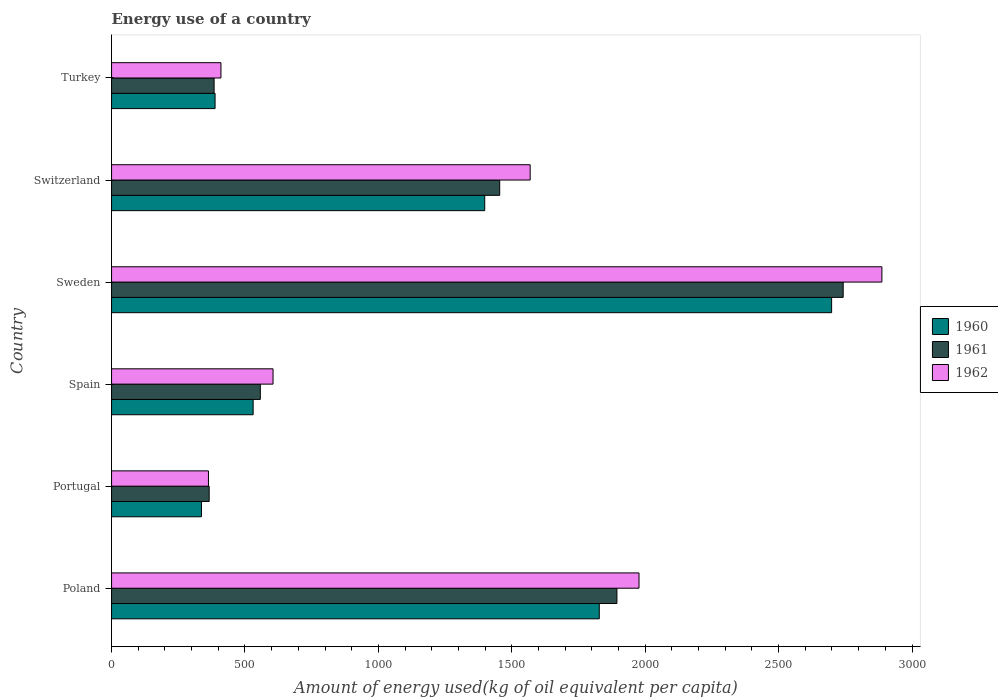How many groups of bars are there?
Provide a succinct answer. 6. How many bars are there on the 1st tick from the bottom?
Provide a succinct answer. 3. What is the label of the 2nd group of bars from the top?
Offer a terse response. Switzerland. What is the amount of energy used in in 1962 in Turkey?
Provide a short and direct response. 410.02. Across all countries, what is the maximum amount of energy used in in 1961?
Your answer should be very brief. 2742.12. Across all countries, what is the minimum amount of energy used in in 1961?
Ensure brevity in your answer.  365.84. In which country was the amount of energy used in in 1961 maximum?
Your response must be concise. Sweden. What is the total amount of energy used in in 1962 in the graph?
Offer a very short reply. 7811.42. What is the difference between the amount of energy used in in 1962 in Sweden and that in Turkey?
Provide a short and direct response. 2477.21. What is the difference between the amount of energy used in in 1962 in Poland and the amount of energy used in in 1960 in Portugal?
Your response must be concise. 1639.95. What is the average amount of energy used in in 1961 per country?
Your answer should be very brief. 1233.12. What is the difference between the amount of energy used in in 1960 and amount of energy used in in 1962 in Spain?
Keep it short and to the point. -74.56. What is the ratio of the amount of energy used in in 1962 in Poland to that in Portugal?
Keep it short and to the point. 5.44. Is the amount of energy used in in 1962 in Sweden less than that in Switzerland?
Your answer should be compact. No. Is the difference between the amount of energy used in in 1960 in Sweden and Turkey greater than the difference between the amount of energy used in in 1962 in Sweden and Turkey?
Offer a very short reply. No. What is the difference between the highest and the second highest amount of energy used in in 1962?
Make the answer very short. 910.38. What is the difference between the highest and the lowest amount of energy used in in 1961?
Give a very brief answer. 2376.28. What does the 1st bar from the bottom in Poland represents?
Ensure brevity in your answer.  1960. Is it the case that in every country, the sum of the amount of energy used in in 1962 and amount of energy used in in 1961 is greater than the amount of energy used in in 1960?
Keep it short and to the point. Yes. What is the difference between two consecutive major ticks on the X-axis?
Your answer should be very brief. 500. How are the legend labels stacked?
Ensure brevity in your answer.  Vertical. What is the title of the graph?
Offer a very short reply. Energy use of a country. What is the label or title of the X-axis?
Give a very brief answer. Amount of energy used(kg of oil equivalent per capita). What is the Amount of energy used(kg of oil equivalent per capita) in 1960 in Poland?
Provide a short and direct response. 1827.94. What is the Amount of energy used(kg of oil equivalent per capita) of 1961 in Poland?
Offer a terse response. 1894.06. What is the Amount of energy used(kg of oil equivalent per capita) of 1962 in Poland?
Your answer should be very brief. 1976.86. What is the Amount of energy used(kg of oil equivalent per capita) of 1960 in Portugal?
Provide a short and direct response. 336.91. What is the Amount of energy used(kg of oil equivalent per capita) in 1961 in Portugal?
Make the answer very short. 365.84. What is the Amount of energy used(kg of oil equivalent per capita) in 1962 in Portugal?
Keep it short and to the point. 363.16. What is the Amount of energy used(kg of oil equivalent per capita) of 1960 in Spain?
Provide a short and direct response. 530.66. What is the Amount of energy used(kg of oil equivalent per capita) of 1961 in Spain?
Provide a short and direct response. 557.6. What is the Amount of energy used(kg of oil equivalent per capita) in 1962 in Spain?
Offer a terse response. 605.22. What is the Amount of energy used(kg of oil equivalent per capita) in 1960 in Sweden?
Your answer should be compact. 2698.79. What is the Amount of energy used(kg of oil equivalent per capita) of 1961 in Sweden?
Ensure brevity in your answer.  2742.12. What is the Amount of energy used(kg of oil equivalent per capita) of 1962 in Sweden?
Your response must be concise. 2887.24. What is the Amount of energy used(kg of oil equivalent per capita) in 1960 in Switzerland?
Keep it short and to the point. 1398.65. What is the Amount of energy used(kg of oil equivalent per capita) in 1961 in Switzerland?
Give a very brief answer. 1454.76. What is the Amount of energy used(kg of oil equivalent per capita) of 1962 in Switzerland?
Your answer should be compact. 1568.91. What is the Amount of energy used(kg of oil equivalent per capita) of 1960 in Turkey?
Ensure brevity in your answer.  387.97. What is the Amount of energy used(kg of oil equivalent per capita) of 1961 in Turkey?
Your answer should be compact. 384.35. What is the Amount of energy used(kg of oil equivalent per capita) in 1962 in Turkey?
Ensure brevity in your answer.  410.02. Across all countries, what is the maximum Amount of energy used(kg of oil equivalent per capita) of 1960?
Your answer should be very brief. 2698.79. Across all countries, what is the maximum Amount of energy used(kg of oil equivalent per capita) in 1961?
Provide a short and direct response. 2742.12. Across all countries, what is the maximum Amount of energy used(kg of oil equivalent per capita) in 1962?
Your response must be concise. 2887.24. Across all countries, what is the minimum Amount of energy used(kg of oil equivalent per capita) in 1960?
Ensure brevity in your answer.  336.91. Across all countries, what is the minimum Amount of energy used(kg of oil equivalent per capita) of 1961?
Your answer should be very brief. 365.84. Across all countries, what is the minimum Amount of energy used(kg of oil equivalent per capita) in 1962?
Keep it short and to the point. 363.16. What is the total Amount of energy used(kg of oil equivalent per capita) in 1960 in the graph?
Provide a short and direct response. 7180.93. What is the total Amount of energy used(kg of oil equivalent per capita) in 1961 in the graph?
Provide a succinct answer. 7398.72. What is the total Amount of energy used(kg of oil equivalent per capita) in 1962 in the graph?
Offer a very short reply. 7811.42. What is the difference between the Amount of energy used(kg of oil equivalent per capita) of 1960 in Poland and that in Portugal?
Provide a short and direct response. 1491.02. What is the difference between the Amount of energy used(kg of oil equivalent per capita) of 1961 in Poland and that in Portugal?
Give a very brief answer. 1528.22. What is the difference between the Amount of energy used(kg of oil equivalent per capita) in 1962 in Poland and that in Portugal?
Provide a succinct answer. 1613.7. What is the difference between the Amount of energy used(kg of oil equivalent per capita) in 1960 in Poland and that in Spain?
Your answer should be very brief. 1297.27. What is the difference between the Amount of energy used(kg of oil equivalent per capita) of 1961 in Poland and that in Spain?
Provide a short and direct response. 1336.46. What is the difference between the Amount of energy used(kg of oil equivalent per capita) of 1962 in Poland and that in Spain?
Make the answer very short. 1371.64. What is the difference between the Amount of energy used(kg of oil equivalent per capita) of 1960 in Poland and that in Sweden?
Your response must be concise. -870.86. What is the difference between the Amount of energy used(kg of oil equivalent per capita) of 1961 in Poland and that in Sweden?
Your answer should be compact. -848.07. What is the difference between the Amount of energy used(kg of oil equivalent per capita) in 1962 in Poland and that in Sweden?
Your answer should be compact. -910.38. What is the difference between the Amount of energy used(kg of oil equivalent per capita) of 1960 in Poland and that in Switzerland?
Provide a short and direct response. 429.28. What is the difference between the Amount of energy used(kg of oil equivalent per capita) in 1961 in Poland and that in Switzerland?
Your answer should be compact. 439.3. What is the difference between the Amount of energy used(kg of oil equivalent per capita) of 1962 in Poland and that in Switzerland?
Offer a very short reply. 407.95. What is the difference between the Amount of energy used(kg of oil equivalent per capita) of 1960 in Poland and that in Turkey?
Keep it short and to the point. 1439.97. What is the difference between the Amount of energy used(kg of oil equivalent per capita) in 1961 in Poland and that in Turkey?
Provide a short and direct response. 1509.71. What is the difference between the Amount of energy used(kg of oil equivalent per capita) in 1962 in Poland and that in Turkey?
Keep it short and to the point. 1566.84. What is the difference between the Amount of energy used(kg of oil equivalent per capita) of 1960 in Portugal and that in Spain?
Offer a very short reply. -193.75. What is the difference between the Amount of energy used(kg of oil equivalent per capita) of 1961 in Portugal and that in Spain?
Your response must be concise. -191.76. What is the difference between the Amount of energy used(kg of oil equivalent per capita) of 1962 in Portugal and that in Spain?
Ensure brevity in your answer.  -242.06. What is the difference between the Amount of energy used(kg of oil equivalent per capita) of 1960 in Portugal and that in Sweden?
Your answer should be compact. -2361.88. What is the difference between the Amount of energy used(kg of oil equivalent per capita) in 1961 in Portugal and that in Sweden?
Your response must be concise. -2376.28. What is the difference between the Amount of energy used(kg of oil equivalent per capita) in 1962 in Portugal and that in Sweden?
Keep it short and to the point. -2524.07. What is the difference between the Amount of energy used(kg of oil equivalent per capita) in 1960 in Portugal and that in Switzerland?
Offer a terse response. -1061.74. What is the difference between the Amount of energy used(kg of oil equivalent per capita) of 1961 in Portugal and that in Switzerland?
Give a very brief answer. -1088.91. What is the difference between the Amount of energy used(kg of oil equivalent per capita) of 1962 in Portugal and that in Switzerland?
Your answer should be compact. -1205.75. What is the difference between the Amount of energy used(kg of oil equivalent per capita) in 1960 in Portugal and that in Turkey?
Ensure brevity in your answer.  -51.06. What is the difference between the Amount of energy used(kg of oil equivalent per capita) in 1961 in Portugal and that in Turkey?
Your response must be concise. -18.51. What is the difference between the Amount of energy used(kg of oil equivalent per capita) of 1962 in Portugal and that in Turkey?
Your answer should be very brief. -46.86. What is the difference between the Amount of energy used(kg of oil equivalent per capita) in 1960 in Spain and that in Sweden?
Your response must be concise. -2168.13. What is the difference between the Amount of energy used(kg of oil equivalent per capita) in 1961 in Spain and that in Sweden?
Your response must be concise. -2184.52. What is the difference between the Amount of energy used(kg of oil equivalent per capita) of 1962 in Spain and that in Sweden?
Provide a short and direct response. -2282.01. What is the difference between the Amount of energy used(kg of oil equivalent per capita) in 1960 in Spain and that in Switzerland?
Provide a short and direct response. -867.99. What is the difference between the Amount of energy used(kg of oil equivalent per capita) of 1961 in Spain and that in Switzerland?
Your answer should be very brief. -897.16. What is the difference between the Amount of energy used(kg of oil equivalent per capita) in 1962 in Spain and that in Switzerland?
Ensure brevity in your answer.  -963.69. What is the difference between the Amount of energy used(kg of oil equivalent per capita) of 1960 in Spain and that in Turkey?
Offer a very short reply. 142.69. What is the difference between the Amount of energy used(kg of oil equivalent per capita) of 1961 in Spain and that in Turkey?
Ensure brevity in your answer.  173.25. What is the difference between the Amount of energy used(kg of oil equivalent per capita) in 1962 in Spain and that in Turkey?
Your response must be concise. 195.2. What is the difference between the Amount of energy used(kg of oil equivalent per capita) in 1960 in Sweden and that in Switzerland?
Offer a terse response. 1300.14. What is the difference between the Amount of energy used(kg of oil equivalent per capita) in 1961 in Sweden and that in Switzerland?
Make the answer very short. 1287.37. What is the difference between the Amount of energy used(kg of oil equivalent per capita) of 1962 in Sweden and that in Switzerland?
Offer a very short reply. 1318.33. What is the difference between the Amount of energy used(kg of oil equivalent per capita) in 1960 in Sweden and that in Turkey?
Provide a short and direct response. 2310.82. What is the difference between the Amount of energy used(kg of oil equivalent per capita) in 1961 in Sweden and that in Turkey?
Your response must be concise. 2357.78. What is the difference between the Amount of energy used(kg of oil equivalent per capita) in 1962 in Sweden and that in Turkey?
Offer a very short reply. 2477.21. What is the difference between the Amount of energy used(kg of oil equivalent per capita) of 1960 in Switzerland and that in Turkey?
Your response must be concise. 1010.68. What is the difference between the Amount of energy used(kg of oil equivalent per capita) in 1961 in Switzerland and that in Turkey?
Offer a terse response. 1070.41. What is the difference between the Amount of energy used(kg of oil equivalent per capita) of 1962 in Switzerland and that in Turkey?
Give a very brief answer. 1158.89. What is the difference between the Amount of energy used(kg of oil equivalent per capita) in 1960 in Poland and the Amount of energy used(kg of oil equivalent per capita) in 1961 in Portugal?
Provide a succinct answer. 1462.1. What is the difference between the Amount of energy used(kg of oil equivalent per capita) in 1960 in Poland and the Amount of energy used(kg of oil equivalent per capita) in 1962 in Portugal?
Make the answer very short. 1464.77. What is the difference between the Amount of energy used(kg of oil equivalent per capita) in 1961 in Poland and the Amount of energy used(kg of oil equivalent per capita) in 1962 in Portugal?
Your answer should be very brief. 1530.89. What is the difference between the Amount of energy used(kg of oil equivalent per capita) in 1960 in Poland and the Amount of energy used(kg of oil equivalent per capita) in 1961 in Spain?
Keep it short and to the point. 1270.34. What is the difference between the Amount of energy used(kg of oil equivalent per capita) in 1960 in Poland and the Amount of energy used(kg of oil equivalent per capita) in 1962 in Spain?
Your answer should be compact. 1222.71. What is the difference between the Amount of energy used(kg of oil equivalent per capita) in 1961 in Poland and the Amount of energy used(kg of oil equivalent per capita) in 1962 in Spain?
Your response must be concise. 1288.83. What is the difference between the Amount of energy used(kg of oil equivalent per capita) in 1960 in Poland and the Amount of energy used(kg of oil equivalent per capita) in 1961 in Sweden?
Ensure brevity in your answer.  -914.19. What is the difference between the Amount of energy used(kg of oil equivalent per capita) in 1960 in Poland and the Amount of energy used(kg of oil equivalent per capita) in 1962 in Sweden?
Give a very brief answer. -1059.3. What is the difference between the Amount of energy used(kg of oil equivalent per capita) of 1961 in Poland and the Amount of energy used(kg of oil equivalent per capita) of 1962 in Sweden?
Your answer should be very brief. -993.18. What is the difference between the Amount of energy used(kg of oil equivalent per capita) of 1960 in Poland and the Amount of energy used(kg of oil equivalent per capita) of 1961 in Switzerland?
Make the answer very short. 373.18. What is the difference between the Amount of energy used(kg of oil equivalent per capita) in 1960 in Poland and the Amount of energy used(kg of oil equivalent per capita) in 1962 in Switzerland?
Offer a terse response. 259.03. What is the difference between the Amount of energy used(kg of oil equivalent per capita) in 1961 in Poland and the Amount of energy used(kg of oil equivalent per capita) in 1962 in Switzerland?
Offer a very short reply. 325.15. What is the difference between the Amount of energy used(kg of oil equivalent per capita) of 1960 in Poland and the Amount of energy used(kg of oil equivalent per capita) of 1961 in Turkey?
Ensure brevity in your answer.  1443.59. What is the difference between the Amount of energy used(kg of oil equivalent per capita) of 1960 in Poland and the Amount of energy used(kg of oil equivalent per capita) of 1962 in Turkey?
Offer a terse response. 1417.91. What is the difference between the Amount of energy used(kg of oil equivalent per capita) of 1961 in Poland and the Amount of energy used(kg of oil equivalent per capita) of 1962 in Turkey?
Your response must be concise. 1484.04. What is the difference between the Amount of energy used(kg of oil equivalent per capita) in 1960 in Portugal and the Amount of energy used(kg of oil equivalent per capita) in 1961 in Spain?
Offer a terse response. -220.69. What is the difference between the Amount of energy used(kg of oil equivalent per capita) in 1960 in Portugal and the Amount of energy used(kg of oil equivalent per capita) in 1962 in Spain?
Ensure brevity in your answer.  -268.31. What is the difference between the Amount of energy used(kg of oil equivalent per capita) in 1961 in Portugal and the Amount of energy used(kg of oil equivalent per capita) in 1962 in Spain?
Your answer should be compact. -239.38. What is the difference between the Amount of energy used(kg of oil equivalent per capita) in 1960 in Portugal and the Amount of energy used(kg of oil equivalent per capita) in 1961 in Sweden?
Offer a very short reply. -2405.21. What is the difference between the Amount of energy used(kg of oil equivalent per capita) of 1960 in Portugal and the Amount of energy used(kg of oil equivalent per capita) of 1962 in Sweden?
Offer a terse response. -2550.32. What is the difference between the Amount of energy used(kg of oil equivalent per capita) of 1961 in Portugal and the Amount of energy used(kg of oil equivalent per capita) of 1962 in Sweden?
Provide a succinct answer. -2521.4. What is the difference between the Amount of energy used(kg of oil equivalent per capita) of 1960 in Portugal and the Amount of energy used(kg of oil equivalent per capita) of 1961 in Switzerland?
Provide a succinct answer. -1117.84. What is the difference between the Amount of energy used(kg of oil equivalent per capita) in 1960 in Portugal and the Amount of energy used(kg of oil equivalent per capita) in 1962 in Switzerland?
Your response must be concise. -1232. What is the difference between the Amount of energy used(kg of oil equivalent per capita) of 1961 in Portugal and the Amount of energy used(kg of oil equivalent per capita) of 1962 in Switzerland?
Keep it short and to the point. -1203.07. What is the difference between the Amount of energy used(kg of oil equivalent per capita) of 1960 in Portugal and the Amount of energy used(kg of oil equivalent per capita) of 1961 in Turkey?
Provide a short and direct response. -47.43. What is the difference between the Amount of energy used(kg of oil equivalent per capita) in 1960 in Portugal and the Amount of energy used(kg of oil equivalent per capita) in 1962 in Turkey?
Give a very brief answer. -73.11. What is the difference between the Amount of energy used(kg of oil equivalent per capita) of 1961 in Portugal and the Amount of energy used(kg of oil equivalent per capita) of 1962 in Turkey?
Ensure brevity in your answer.  -44.18. What is the difference between the Amount of energy used(kg of oil equivalent per capita) of 1960 in Spain and the Amount of energy used(kg of oil equivalent per capita) of 1961 in Sweden?
Offer a terse response. -2211.46. What is the difference between the Amount of energy used(kg of oil equivalent per capita) in 1960 in Spain and the Amount of energy used(kg of oil equivalent per capita) in 1962 in Sweden?
Your response must be concise. -2356.57. What is the difference between the Amount of energy used(kg of oil equivalent per capita) of 1961 in Spain and the Amount of energy used(kg of oil equivalent per capita) of 1962 in Sweden?
Your answer should be very brief. -2329.64. What is the difference between the Amount of energy used(kg of oil equivalent per capita) in 1960 in Spain and the Amount of energy used(kg of oil equivalent per capita) in 1961 in Switzerland?
Keep it short and to the point. -924.09. What is the difference between the Amount of energy used(kg of oil equivalent per capita) in 1960 in Spain and the Amount of energy used(kg of oil equivalent per capita) in 1962 in Switzerland?
Your response must be concise. -1038.25. What is the difference between the Amount of energy used(kg of oil equivalent per capita) in 1961 in Spain and the Amount of energy used(kg of oil equivalent per capita) in 1962 in Switzerland?
Give a very brief answer. -1011.31. What is the difference between the Amount of energy used(kg of oil equivalent per capita) in 1960 in Spain and the Amount of energy used(kg of oil equivalent per capita) in 1961 in Turkey?
Your response must be concise. 146.32. What is the difference between the Amount of energy used(kg of oil equivalent per capita) in 1960 in Spain and the Amount of energy used(kg of oil equivalent per capita) in 1962 in Turkey?
Offer a very short reply. 120.64. What is the difference between the Amount of energy used(kg of oil equivalent per capita) in 1961 in Spain and the Amount of energy used(kg of oil equivalent per capita) in 1962 in Turkey?
Ensure brevity in your answer.  147.58. What is the difference between the Amount of energy used(kg of oil equivalent per capita) in 1960 in Sweden and the Amount of energy used(kg of oil equivalent per capita) in 1961 in Switzerland?
Your answer should be very brief. 1244.04. What is the difference between the Amount of energy used(kg of oil equivalent per capita) in 1960 in Sweden and the Amount of energy used(kg of oil equivalent per capita) in 1962 in Switzerland?
Keep it short and to the point. 1129.88. What is the difference between the Amount of energy used(kg of oil equivalent per capita) in 1961 in Sweden and the Amount of energy used(kg of oil equivalent per capita) in 1962 in Switzerland?
Your response must be concise. 1173.21. What is the difference between the Amount of energy used(kg of oil equivalent per capita) in 1960 in Sweden and the Amount of energy used(kg of oil equivalent per capita) in 1961 in Turkey?
Make the answer very short. 2314.45. What is the difference between the Amount of energy used(kg of oil equivalent per capita) in 1960 in Sweden and the Amount of energy used(kg of oil equivalent per capita) in 1962 in Turkey?
Offer a terse response. 2288.77. What is the difference between the Amount of energy used(kg of oil equivalent per capita) in 1961 in Sweden and the Amount of energy used(kg of oil equivalent per capita) in 1962 in Turkey?
Ensure brevity in your answer.  2332.1. What is the difference between the Amount of energy used(kg of oil equivalent per capita) in 1960 in Switzerland and the Amount of energy used(kg of oil equivalent per capita) in 1961 in Turkey?
Provide a short and direct response. 1014.31. What is the difference between the Amount of energy used(kg of oil equivalent per capita) of 1960 in Switzerland and the Amount of energy used(kg of oil equivalent per capita) of 1962 in Turkey?
Your answer should be very brief. 988.63. What is the difference between the Amount of energy used(kg of oil equivalent per capita) of 1961 in Switzerland and the Amount of energy used(kg of oil equivalent per capita) of 1962 in Turkey?
Your answer should be compact. 1044.73. What is the average Amount of energy used(kg of oil equivalent per capita) in 1960 per country?
Provide a succinct answer. 1196.82. What is the average Amount of energy used(kg of oil equivalent per capita) of 1961 per country?
Offer a very short reply. 1233.12. What is the average Amount of energy used(kg of oil equivalent per capita) of 1962 per country?
Offer a terse response. 1301.9. What is the difference between the Amount of energy used(kg of oil equivalent per capita) of 1960 and Amount of energy used(kg of oil equivalent per capita) of 1961 in Poland?
Provide a short and direct response. -66.12. What is the difference between the Amount of energy used(kg of oil equivalent per capita) of 1960 and Amount of energy used(kg of oil equivalent per capita) of 1962 in Poland?
Provide a succinct answer. -148.92. What is the difference between the Amount of energy used(kg of oil equivalent per capita) in 1961 and Amount of energy used(kg of oil equivalent per capita) in 1962 in Poland?
Provide a short and direct response. -82.8. What is the difference between the Amount of energy used(kg of oil equivalent per capita) in 1960 and Amount of energy used(kg of oil equivalent per capita) in 1961 in Portugal?
Ensure brevity in your answer.  -28.93. What is the difference between the Amount of energy used(kg of oil equivalent per capita) of 1960 and Amount of energy used(kg of oil equivalent per capita) of 1962 in Portugal?
Your response must be concise. -26.25. What is the difference between the Amount of energy used(kg of oil equivalent per capita) in 1961 and Amount of energy used(kg of oil equivalent per capita) in 1962 in Portugal?
Provide a short and direct response. 2.68. What is the difference between the Amount of energy used(kg of oil equivalent per capita) of 1960 and Amount of energy used(kg of oil equivalent per capita) of 1961 in Spain?
Offer a terse response. -26.93. What is the difference between the Amount of energy used(kg of oil equivalent per capita) of 1960 and Amount of energy used(kg of oil equivalent per capita) of 1962 in Spain?
Your answer should be very brief. -74.56. What is the difference between the Amount of energy used(kg of oil equivalent per capita) in 1961 and Amount of energy used(kg of oil equivalent per capita) in 1962 in Spain?
Offer a very short reply. -47.62. What is the difference between the Amount of energy used(kg of oil equivalent per capita) in 1960 and Amount of energy used(kg of oil equivalent per capita) in 1961 in Sweden?
Your answer should be very brief. -43.33. What is the difference between the Amount of energy used(kg of oil equivalent per capita) of 1960 and Amount of energy used(kg of oil equivalent per capita) of 1962 in Sweden?
Ensure brevity in your answer.  -188.44. What is the difference between the Amount of energy used(kg of oil equivalent per capita) in 1961 and Amount of energy used(kg of oil equivalent per capita) in 1962 in Sweden?
Offer a terse response. -145.11. What is the difference between the Amount of energy used(kg of oil equivalent per capita) in 1960 and Amount of energy used(kg of oil equivalent per capita) in 1961 in Switzerland?
Your answer should be compact. -56.1. What is the difference between the Amount of energy used(kg of oil equivalent per capita) in 1960 and Amount of energy used(kg of oil equivalent per capita) in 1962 in Switzerland?
Give a very brief answer. -170.26. What is the difference between the Amount of energy used(kg of oil equivalent per capita) in 1961 and Amount of energy used(kg of oil equivalent per capita) in 1962 in Switzerland?
Keep it short and to the point. -114.16. What is the difference between the Amount of energy used(kg of oil equivalent per capita) of 1960 and Amount of energy used(kg of oil equivalent per capita) of 1961 in Turkey?
Keep it short and to the point. 3.62. What is the difference between the Amount of energy used(kg of oil equivalent per capita) of 1960 and Amount of energy used(kg of oil equivalent per capita) of 1962 in Turkey?
Offer a terse response. -22.05. What is the difference between the Amount of energy used(kg of oil equivalent per capita) of 1961 and Amount of energy used(kg of oil equivalent per capita) of 1962 in Turkey?
Keep it short and to the point. -25.68. What is the ratio of the Amount of energy used(kg of oil equivalent per capita) of 1960 in Poland to that in Portugal?
Your answer should be very brief. 5.43. What is the ratio of the Amount of energy used(kg of oil equivalent per capita) of 1961 in Poland to that in Portugal?
Keep it short and to the point. 5.18. What is the ratio of the Amount of energy used(kg of oil equivalent per capita) in 1962 in Poland to that in Portugal?
Keep it short and to the point. 5.44. What is the ratio of the Amount of energy used(kg of oil equivalent per capita) of 1960 in Poland to that in Spain?
Ensure brevity in your answer.  3.44. What is the ratio of the Amount of energy used(kg of oil equivalent per capita) of 1961 in Poland to that in Spain?
Provide a succinct answer. 3.4. What is the ratio of the Amount of energy used(kg of oil equivalent per capita) of 1962 in Poland to that in Spain?
Your response must be concise. 3.27. What is the ratio of the Amount of energy used(kg of oil equivalent per capita) in 1960 in Poland to that in Sweden?
Provide a succinct answer. 0.68. What is the ratio of the Amount of energy used(kg of oil equivalent per capita) in 1961 in Poland to that in Sweden?
Ensure brevity in your answer.  0.69. What is the ratio of the Amount of energy used(kg of oil equivalent per capita) in 1962 in Poland to that in Sweden?
Your response must be concise. 0.68. What is the ratio of the Amount of energy used(kg of oil equivalent per capita) of 1960 in Poland to that in Switzerland?
Keep it short and to the point. 1.31. What is the ratio of the Amount of energy used(kg of oil equivalent per capita) of 1961 in Poland to that in Switzerland?
Offer a terse response. 1.3. What is the ratio of the Amount of energy used(kg of oil equivalent per capita) in 1962 in Poland to that in Switzerland?
Offer a very short reply. 1.26. What is the ratio of the Amount of energy used(kg of oil equivalent per capita) in 1960 in Poland to that in Turkey?
Provide a succinct answer. 4.71. What is the ratio of the Amount of energy used(kg of oil equivalent per capita) of 1961 in Poland to that in Turkey?
Offer a terse response. 4.93. What is the ratio of the Amount of energy used(kg of oil equivalent per capita) of 1962 in Poland to that in Turkey?
Make the answer very short. 4.82. What is the ratio of the Amount of energy used(kg of oil equivalent per capita) in 1960 in Portugal to that in Spain?
Offer a very short reply. 0.63. What is the ratio of the Amount of energy used(kg of oil equivalent per capita) of 1961 in Portugal to that in Spain?
Ensure brevity in your answer.  0.66. What is the ratio of the Amount of energy used(kg of oil equivalent per capita) of 1962 in Portugal to that in Spain?
Offer a very short reply. 0.6. What is the ratio of the Amount of energy used(kg of oil equivalent per capita) in 1960 in Portugal to that in Sweden?
Your answer should be very brief. 0.12. What is the ratio of the Amount of energy used(kg of oil equivalent per capita) of 1961 in Portugal to that in Sweden?
Offer a very short reply. 0.13. What is the ratio of the Amount of energy used(kg of oil equivalent per capita) of 1962 in Portugal to that in Sweden?
Offer a terse response. 0.13. What is the ratio of the Amount of energy used(kg of oil equivalent per capita) of 1960 in Portugal to that in Switzerland?
Provide a short and direct response. 0.24. What is the ratio of the Amount of energy used(kg of oil equivalent per capita) in 1961 in Portugal to that in Switzerland?
Keep it short and to the point. 0.25. What is the ratio of the Amount of energy used(kg of oil equivalent per capita) of 1962 in Portugal to that in Switzerland?
Your response must be concise. 0.23. What is the ratio of the Amount of energy used(kg of oil equivalent per capita) of 1960 in Portugal to that in Turkey?
Make the answer very short. 0.87. What is the ratio of the Amount of energy used(kg of oil equivalent per capita) of 1961 in Portugal to that in Turkey?
Provide a short and direct response. 0.95. What is the ratio of the Amount of energy used(kg of oil equivalent per capita) of 1962 in Portugal to that in Turkey?
Provide a short and direct response. 0.89. What is the ratio of the Amount of energy used(kg of oil equivalent per capita) in 1960 in Spain to that in Sweden?
Your response must be concise. 0.2. What is the ratio of the Amount of energy used(kg of oil equivalent per capita) in 1961 in Spain to that in Sweden?
Your response must be concise. 0.2. What is the ratio of the Amount of energy used(kg of oil equivalent per capita) in 1962 in Spain to that in Sweden?
Offer a very short reply. 0.21. What is the ratio of the Amount of energy used(kg of oil equivalent per capita) in 1960 in Spain to that in Switzerland?
Your answer should be compact. 0.38. What is the ratio of the Amount of energy used(kg of oil equivalent per capita) in 1961 in Spain to that in Switzerland?
Give a very brief answer. 0.38. What is the ratio of the Amount of energy used(kg of oil equivalent per capita) in 1962 in Spain to that in Switzerland?
Provide a short and direct response. 0.39. What is the ratio of the Amount of energy used(kg of oil equivalent per capita) of 1960 in Spain to that in Turkey?
Your answer should be compact. 1.37. What is the ratio of the Amount of energy used(kg of oil equivalent per capita) in 1961 in Spain to that in Turkey?
Offer a very short reply. 1.45. What is the ratio of the Amount of energy used(kg of oil equivalent per capita) in 1962 in Spain to that in Turkey?
Make the answer very short. 1.48. What is the ratio of the Amount of energy used(kg of oil equivalent per capita) in 1960 in Sweden to that in Switzerland?
Keep it short and to the point. 1.93. What is the ratio of the Amount of energy used(kg of oil equivalent per capita) in 1961 in Sweden to that in Switzerland?
Your answer should be compact. 1.88. What is the ratio of the Amount of energy used(kg of oil equivalent per capita) of 1962 in Sweden to that in Switzerland?
Provide a short and direct response. 1.84. What is the ratio of the Amount of energy used(kg of oil equivalent per capita) of 1960 in Sweden to that in Turkey?
Your answer should be compact. 6.96. What is the ratio of the Amount of energy used(kg of oil equivalent per capita) of 1961 in Sweden to that in Turkey?
Provide a short and direct response. 7.13. What is the ratio of the Amount of energy used(kg of oil equivalent per capita) in 1962 in Sweden to that in Turkey?
Give a very brief answer. 7.04. What is the ratio of the Amount of energy used(kg of oil equivalent per capita) in 1960 in Switzerland to that in Turkey?
Ensure brevity in your answer.  3.61. What is the ratio of the Amount of energy used(kg of oil equivalent per capita) of 1961 in Switzerland to that in Turkey?
Make the answer very short. 3.79. What is the ratio of the Amount of energy used(kg of oil equivalent per capita) of 1962 in Switzerland to that in Turkey?
Offer a terse response. 3.83. What is the difference between the highest and the second highest Amount of energy used(kg of oil equivalent per capita) in 1960?
Your answer should be very brief. 870.86. What is the difference between the highest and the second highest Amount of energy used(kg of oil equivalent per capita) in 1961?
Provide a short and direct response. 848.07. What is the difference between the highest and the second highest Amount of energy used(kg of oil equivalent per capita) in 1962?
Offer a terse response. 910.38. What is the difference between the highest and the lowest Amount of energy used(kg of oil equivalent per capita) of 1960?
Your answer should be very brief. 2361.88. What is the difference between the highest and the lowest Amount of energy used(kg of oil equivalent per capita) of 1961?
Make the answer very short. 2376.28. What is the difference between the highest and the lowest Amount of energy used(kg of oil equivalent per capita) in 1962?
Your answer should be compact. 2524.07. 